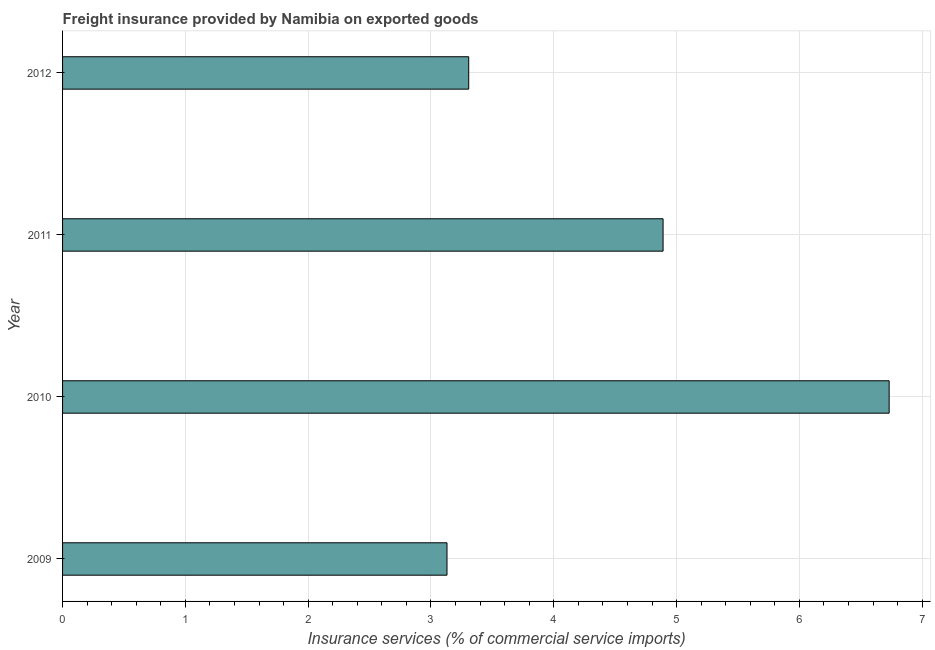Does the graph contain any zero values?
Provide a short and direct response. No. Does the graph contain grids?
Provide a short and direct response. Yes. What is the title of the graph?
Your response must be concise. Freight insurance provided by Namibia on exported goods . What is the label or title of the X-axis?
Provide a short and direct response. Insurance services (% of commercial service imports). What is the freight insurance in 2009?
Provide a succinct answer. 3.13. Across all years, what is the maximum freight insurance?
Your answer should be very brief. 6.73. Across all years, what is the minimum freight insurance?
Ensure brevity in your answer.  3.13. In which year was the freight insurance minimum?
Provide a short and direct response. 2009. What is the sum of the freight insurance?
Offer a very short reply. 18.06. What is the difference between the freight insurance in 2009 and 2011?
Make the answer very short. -1.76. What is the average freight insurance per year?
Give a very brief answer. 4.51. What is the median freight insurance?
Give a very brief answer. 4.1. In how many years, is the freight insurance greater than 2 %?
Offer a terse response. 4. What is the ratio of the freight insurance in 2009 to that in 2010?
Keep it short and to the point. 0.47. What is the difference between the highest and the second highest freight insurance?
Make the answer very short. 1.84. How many bars are there?
Make the answer very short. 4. What is the Insurance services (% of commercial service imports) in 2009?
Your response must be concise. 3.13. What is the Insurance services (% of commercial service imports) of 2010?
Your answer should be very brief. 6.73. What is the Insurance services (% of commercial service imports) of 2011?
Offer a terse response. 4.89. What is the Insurance services (% of commercial service imports) in 2012?
Your answer should be compact. 3.31. What is the difference between the Insurance services (% of commercial service imports) in 2009 and 2010?
Provide a short and direct response. -3.6. What is the difference between the Insurance services (% of commercial service imports) in 2009 and 2011?
Give a very brief answer. -1.76. What is the difference between the Insurance services (% of commercial service imports) in 2009 and 2012?
Ensure brevity in your answer.  -0.18. What is the difference between the Insurance services (% of commercial service imports) in 2010 and 2011?
Offer a very short reply. 1.84. What is the difference between the Insurance services (% of commercial service imports) in 2010 and 2012?
Offer a terse response. 3.42. What is the difference between the Insurance services (% of commercial service imports) in 2011 and 2012?
Ensure brevity in your answer.  1.58. What is the ratio of the Insurance services (% of commercial service imports) in 2009 to that in 2010?
Make the answer very short. 0.47. What is the ratio of the Insurance services (% of commercial service imports) in 2009 to that in 2011?
Your answer should be very brief. 0.64. What is the ratio of the Insurance services (% of commercial service imports) in 2009 to that in 2012?
Provide a succinct answer. 0.95. What is the ratio of the Insurance services (% of commercial service imports) in 2010 to that in 2011?
Your answer should be very brief. 1.38. What is the ratio of the Insurance services (% of commercial service imports) in 2010 to that in 2012?
Ensure brevity in your answer.  2.04. What is the ratio of the Insurance services (% of commercial service imports) in 2011 to that in 2012?
Make the answer very short. 1.48. 